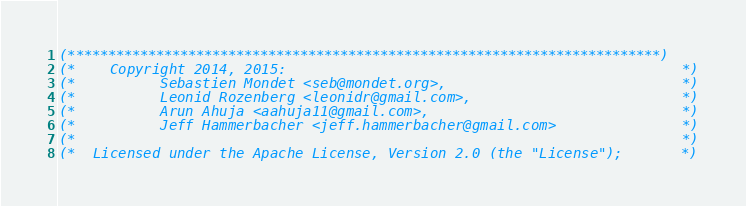Convert code to text. <code><loc_0><loc_0><loc_500><loc_500><_OCaml_>(**************************************************************************)
(*    Copyright 2014, 2015:                                               *)
(*          Sebastien Mondet <seb@mondet.org>,                            *)
(*          Leonid Rozenberg <leonidr@gmail.com>,                         *)
(*          Arun Ahuja <aahuja11@gmail.com>,                              *)
(*          Jeff Hammerbacher <jeff.hammerbacher@gmail.com>               *)
(*                                                                        *)
(*  Licensed under the Apache License, Version 2.0 (the "License");       *)</code> 